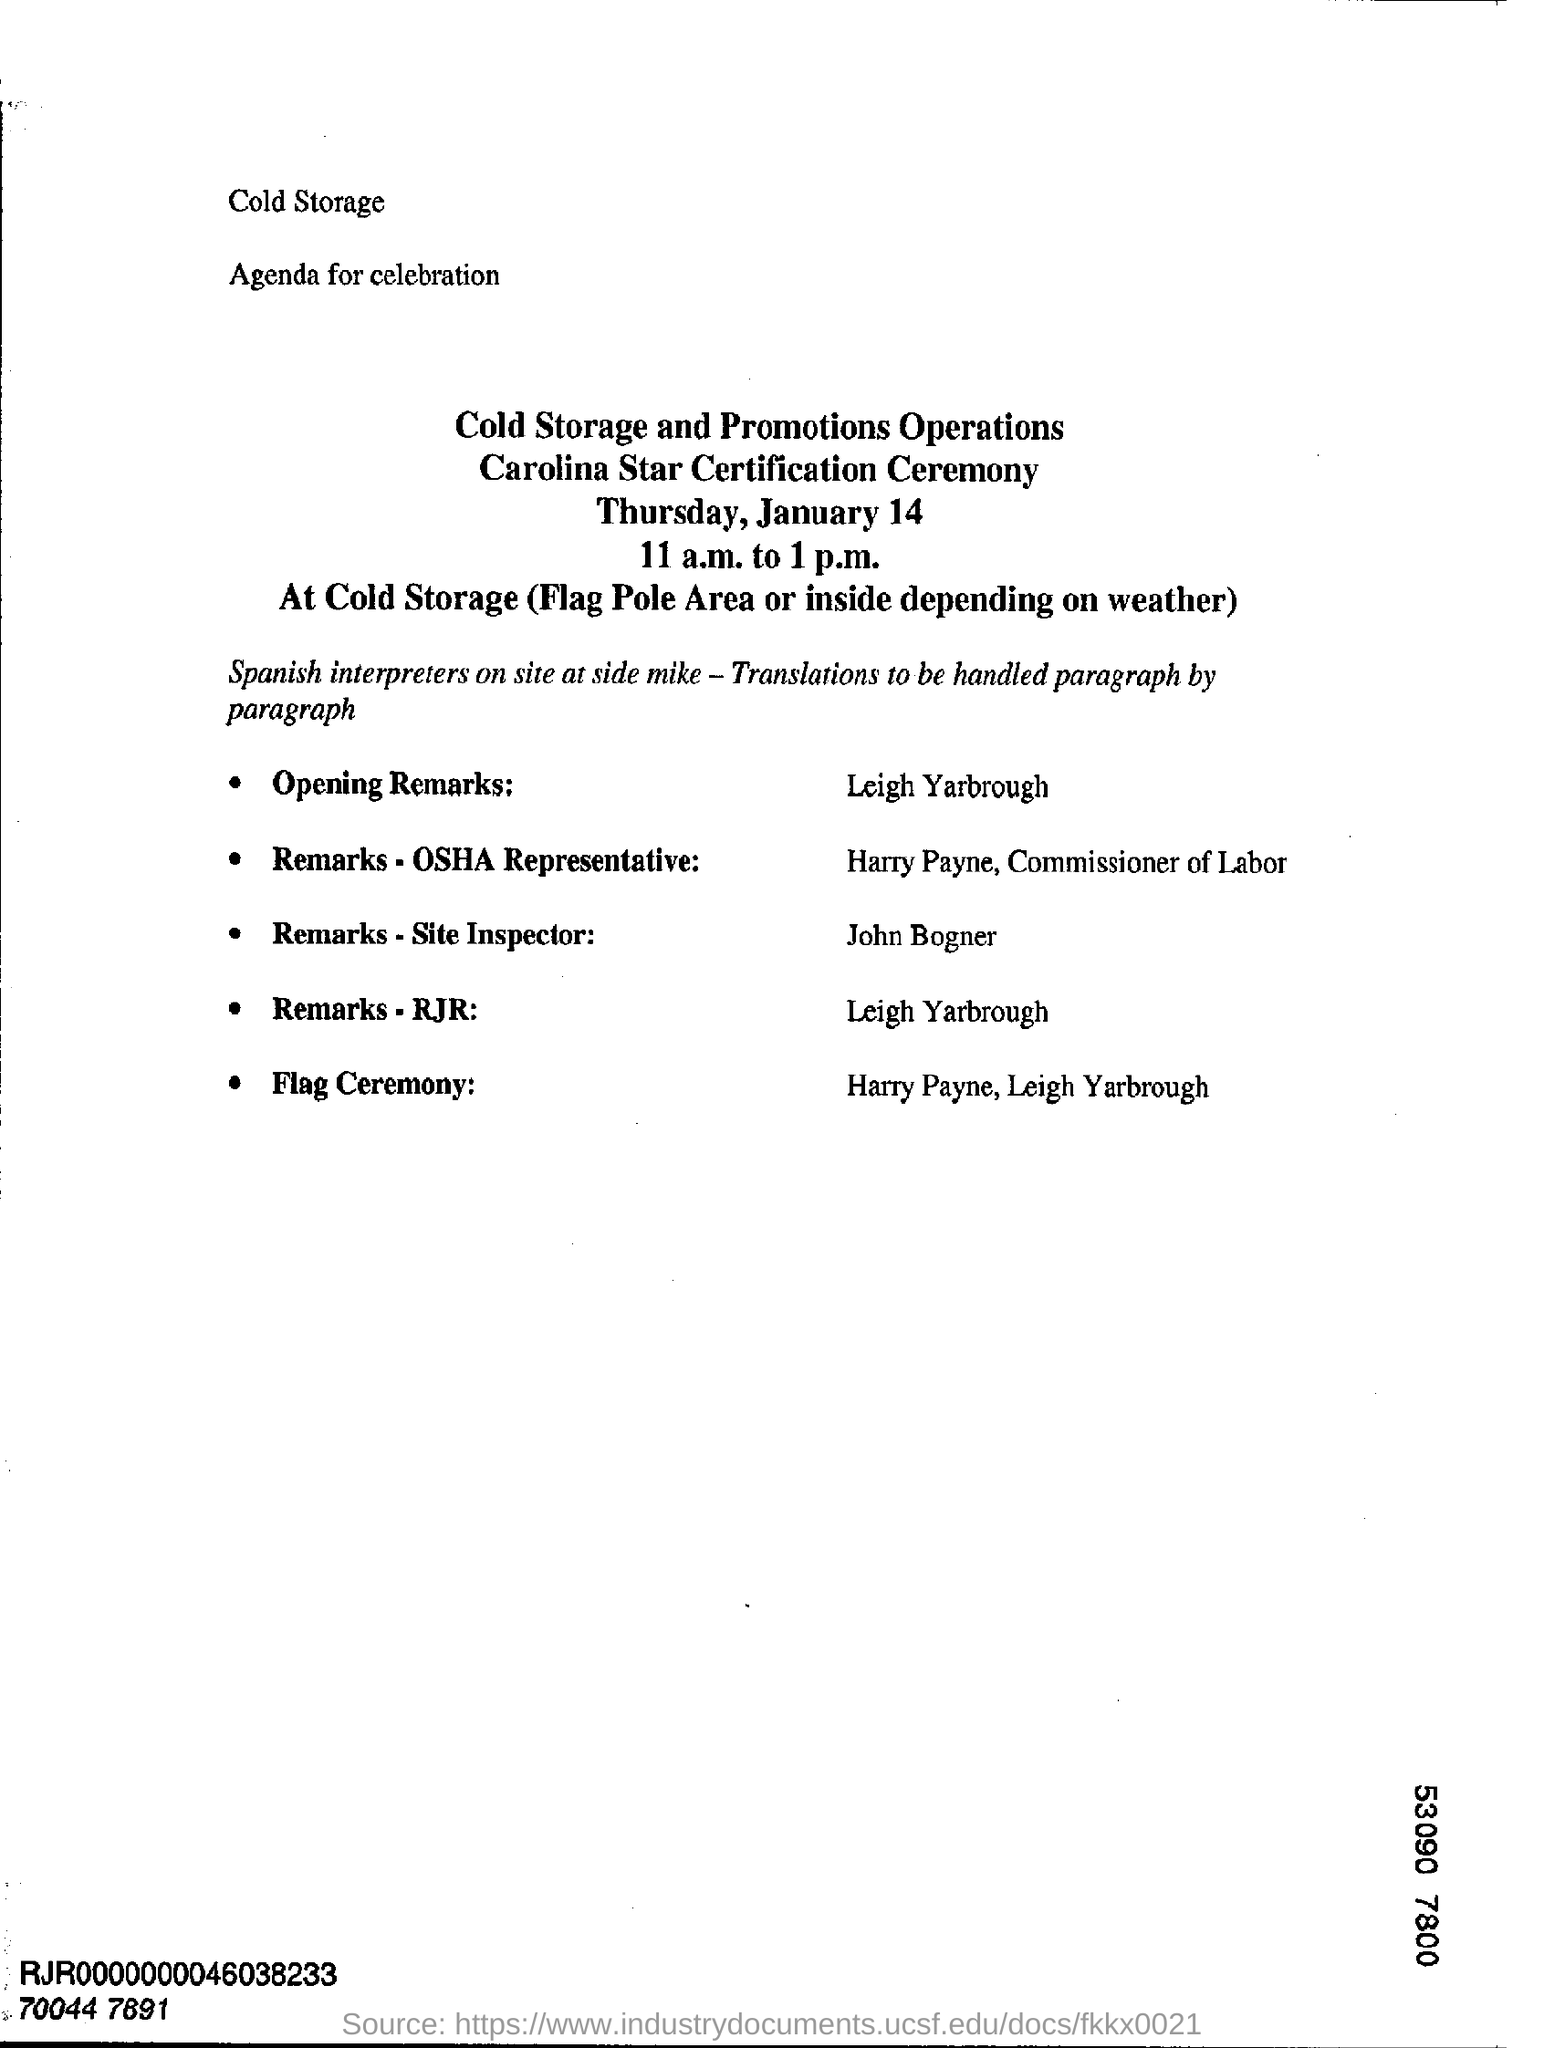What day of the week is january 14?
Ensure brevity in your answer.  Thursday. Who is giving the opening remarks ?
Offer a terse response. Leigh Yarbrough. What is the venue of the carolina star certification ceremony?
Keep it short and to the point. At Cold Storage (Flag Pole Area or inside depending on weather). 